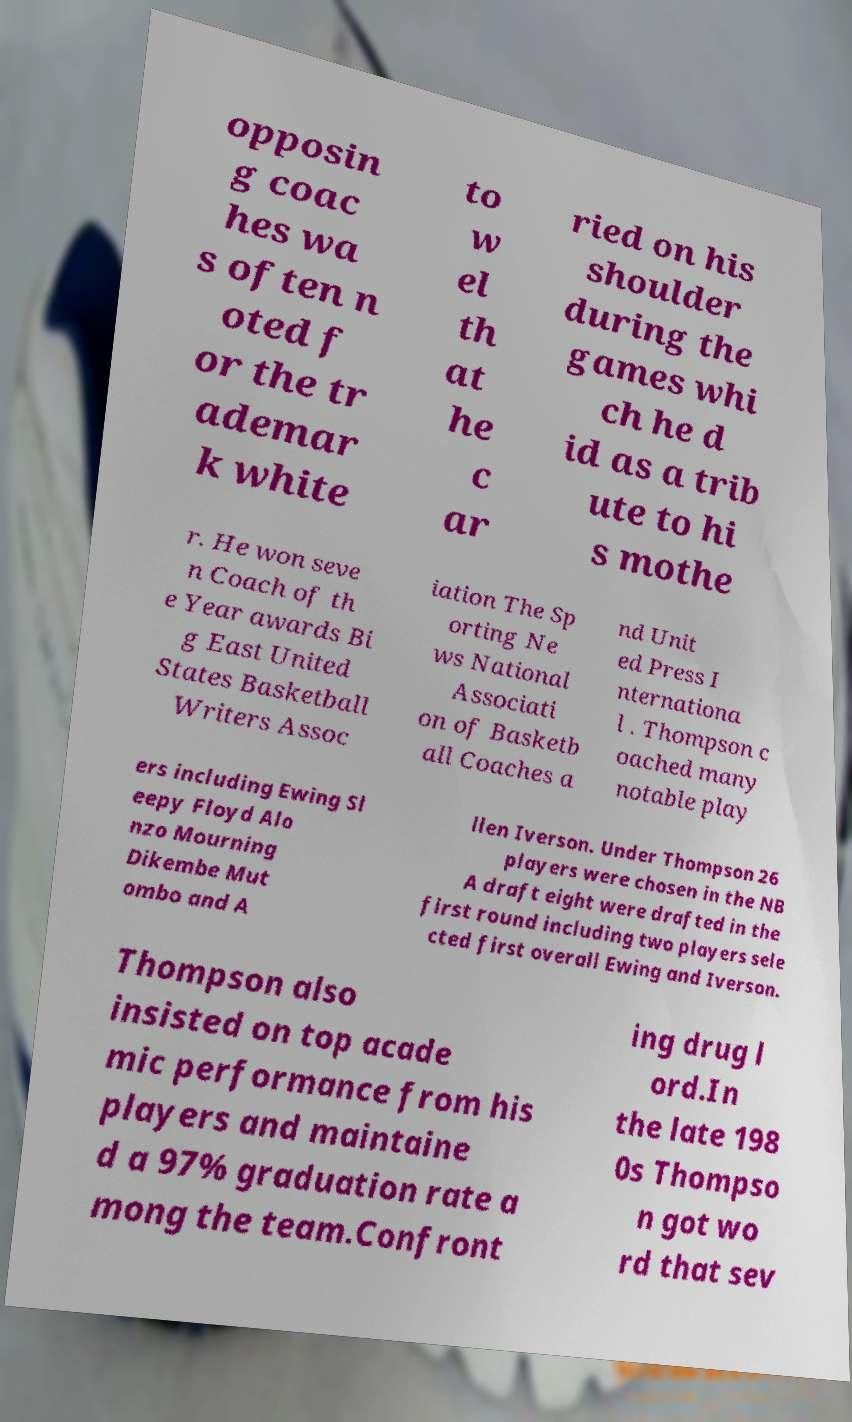Please identify and transcribe the text found in this image. opposin g coac hes wa s often n oted f or the tr ademar k white to w el th at he c ar ried on his shoulder during the games whi ch he d id as a trib ute to hi s mothe r. He won seve n Coach of th e Year awards Bi g East United States Basketball Writers Assoc iation The Sp orting Ne ws National Associati on of Basketb all Coaches a nd Unit ed Press I nternationa l . Thompson c oached many notable play ers including Ewing Sl eepy Floyd Alo nzo Mourning Dikembe Mut ombo and A llen Iverson. Under Thompson 26 players were chosen in the NB A draft eight were drafted in the first round including two players sele cted first overall Ewing and Iverson. Thompson also insisted on top acade mic performance from his players and maintaine d a 97% graduation rate a mong the team.Confront ing drug l ord.In the late 198 0s Thompso n got wo rd that sev 